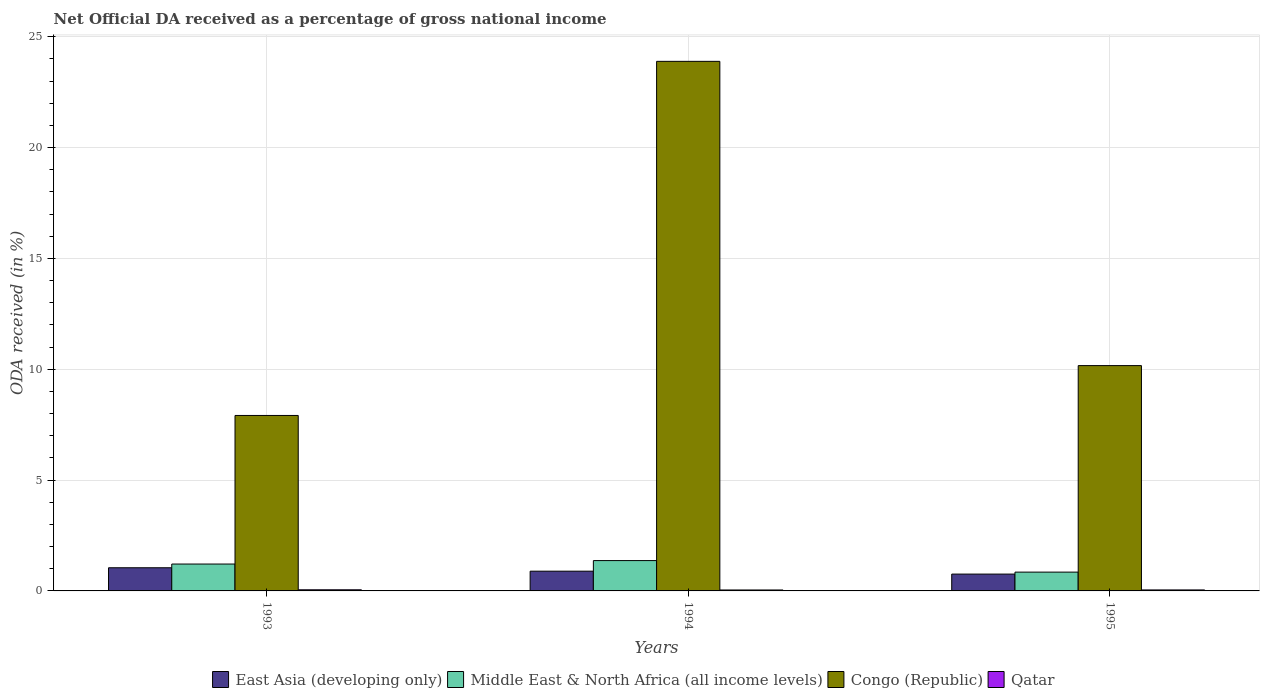Are the number of bars per tick equal to the number of legend labels?
Offer a very short reply. Yes. Are the number of bars on each tick of the X-axis equal?
Ensure brevity in your answer.  Yes. How many bars are there on the 1st tick from the right?
Make the answer very short. 4. What is the label of the 2nd group of bars from the left?
Provide a succinct answer. 1994. In how many cases, is the number of bars for a given year not equal to the number of legend labels?
Keep it short and to the point. 0. What is the net official DA received in Middle East & North Africa (all income levels) in 1994?
Offer a very short reply. 1.37. Across all years, what is the maximum net official DA received in East Asia (developing only)?
Your answer should be compact. 1.05. Across all years, what is the minimum net official DA received in East Asia (developing only)?
Your answer should be compact. 0.76. In which year was the net official DA received in Middle East & North Africa (all income levels) maximum?
Ensure brevity in your answer.  1994. In which year was the net official DA received in Qatar minimum?
Keep it short and to the point. 1994. What is the total net official DA received in East Asia (developing only) in the graph?
Offer a terse response. 2.7. What is the difference between the net official DA received in Congo (Republic) in 1993 and that in 1994?
Provide a succinct answer. -15.98. What is the difference between the net official DA received in East Asia (developing only) in 1993 and the net official DA received in Qatar in 1994?
Keep it short and to the point. 1. What is the average net official DA received in East Asia (developing only) per year?
Make the answer very short. 0.9. In the year 1993, what is the difference between the net official DA received in Qatar and net official DA received in East Asia (developing only)?
Provide a succinct answer. -0.99. In how many years, is the net official DA received in Congo (Republic) greater than 2 %?
Give a very brief answer. 3. What is the ratio of the net official DA received in Qatar in 1993 to that in 1995?
Make the answer very short. 1.15. Is the net official DA received in Middle East & North Africa (all income levels) in 1993 less than that in 1995?
Offer a very short reply. No. Is the difference between the net official DA received in Qatar in 1993 and 1995 greater than the difference between the net official DA received in East Asia (developing only) in 1993 and 1995?
Make the answer very short. No. What is the difference between the highest and the second highest net official DA received in Congo (Republic)?
Make the answer very short. 13.73. What is the difference between the highest and the lowest net official DA received in Middle East & North Africa (all income levels)?
Keep it short and to the point. 0.52. In how many years, is the net official DA received in Middle East & North Africa (all income levels) greater than the average net official DA received in Middle East & North Africa (all income levels) taken over all years?
Your answer should be very brief. 2. Is it the case that in every year, the sum of the net official DA received in Qatar and net official DA received in Middle East & North Africa (all income levels) is greater than the sum of net official DA received in Congo (Republic) and net official DA received in East Asia (developing only)?
Your answer should be very brief. No. What does the 2nd bar from the left in 1993 represents?
Keep it short and to the point. Middle East & North Africa (all income levels). What does the 4th bar from the right in 1994 represents?
Your answer should be compact. East Asia (developing only). Is it the case that in every year, the sum of the net official DA received in Congo (Republic) and net official DA received in East Asia (developing only) is greater than the net official DA received in Middle East & North Africa (all income levels)?
Make the answer very short. Yes. How many bars are there?
Offer a terse response. 12. Are all the bars in the graph horizontal?
Give a very brief answer. No. How many years are there in the graph?
Keep it short and to the point. 3. Where does the legend appear in the graph?
Offer a terse response. Bottom center. How many legend labels are there?
Ensure brevity in your answer.  4. How are the legend labels stacked?
Your response must be concise. Horizontal. What is the title of the graph?
Provide a short and direct response. Net Official DA received as a percentage of gross national income. What is the label or title of the X-axis?
Your answer should be compact. Years. What is the label or title of the Y-axis?
Provide a succinct answer. ODA received (in %). What is the ODA received (in %) of East Asia (developing only) in 1993?
Ensure brevity in your answer.  1.05. What is the ODA received (in %) in Middle East & North Africa (all income levels) in 1993?
Make the answer very short. 1.21. What is the ODA received (in %) of Congo (Republic) in 1993?
Give a very brief answer. 7.92. What is the ODA received (in %) of Qatar in 1993?
Offer a very short reply. 0.05. What is the ODA received (in %) of East Asia (developing only) in 1994?
Your response must be concise. 0.89. What is the ODA received (in %) in Middle East & North Africa (all income levels) in 1994?
Your response must be concise. 1.37. What is the ODA received (in %) in Congo (Republic) in 1994?
Your answer should be compact. 23.89. What is the ODA received (in %) of Qatar in 1994?
Keep it short and to the point. 0.04. What is the ODA received (in %) in East Asia (developing only) in 1995?
Your answer should be compact. 0.76. What is the ODA received (in %) in Middle East & North Africa (all income levels) in 1995?
Provide a succinct answer. 0.85. What is the ODA received (in %) in Congo (Republic) in 1995?
Ensure brevity in your answer.  10.17. What is the ODA received (in %) of Qatar in 1995?
Offer a terse response. 0.04. Across all years, what is the maximum ODA received (in %) in East Asia (developing only)?
Your answer should be very brief. 1.05. Across all years, what is the maximum ODA received (in %) in Middle East & North Africa (all income levels)?
Your answer should be very brief. 1.37. Across all years, what is the maximum ODA received (in %) in Congo (Republic)?
Your response must be concise. 23.89. Across all years, what is the maximum ODA received (in %) of Qatar?
Offer a terse response. 0.05. Across all years, what is the minimum ODA received (in %) in East Asia (developing only)?
Your answer should be compact. 0.76. Across all years, what is the minimum ODA received (in %) of Middle East & North Africa (all income levels)?
Provide a succinct answer. 0.85. Across all years, what is the minimum ODA received (in %) in Congo (Republic)?
Your response must be concise. 7.92. Across all years, what is the minimum ODA received (in %) in Qatar?
Your response must be concise. 0.04. What is the total ODA received (in %) of East Asia (developing only) in the graph?
Offer a terse response. 2.7. What is the total ODA received (in %) in Middle East & North Africa (all income levels) in the graph?
Make the answer very short. 3.43. What is the total ODA received (in %) in Congo (Republic) in the graph?
Your response must be concise. 41.97. What is the total ODA received (in %) in Qatar in the graph?
Your answer should be compact. 0.14. What is the difference between the ODA received (in %) in East Asia (developing only) in 1993 and that in 1994?
Offer a very short reply. 0.15. What is the difference between the ODA received (in %) in Middle East & North Africa (all income levels) in 1993 and that in 1994?
Your answer should be compact. -0.16. What is the difference between the ODA received (in %) in Congo (Republic) in 1993 and that in 1994?
Your answer should be very brief. -15.98. What is the difference between the ODA received (in %) in Qatar in 1993 and that in 1994?
Give a very brief answer. 0.01. What is the difference between the ODA received (in %) in East Asia (developing only) in 1993 and that in 1995?
Keep it short and to the point. 0.29. What is the difference between the ODA received (in %) in Middle East & North Africa (all income levels) in 1993 and that in 1995?
Keep it short and to the point. 0.36. What is the difference between the ODA received (in %) of Congo (Republic) in 1993 and that in 1995?
Give a very brief answer. -2.25. What is the difference between the ODA received (in %) of Qatar in 1993 and that in 1995?
Offer a very short reply. 0.01. What is the difference between the ODA received (in %) in East Asia (developing only) in 1994 and that in 1995?
Keep it short and to the point. 0.13. What is the difference between the ODA received (in %) in Middle East & North Africa (all income levels) in 1994 and that in 1995?
Your response must be concise. 0.52. What is the difference between the ODA received (in %) in Congo (Republic) in 1994 and that in 1995?
Provide a succinct answer. 13.73. What is the difference between the ODA received (in %) in Qatar in 1994 and that in 1995?
Your answer should be compact. -0. What is the difference between the ODA received (in %) in East Asia (developing only) in 1993 and the ODA received (in %) in Middle East & North Africa (all income levels) in 1994?
Offer a terse response. -0.32. What is the difference between the ODA received (in %) in East Asia (developing only) in 1993 and the ODA received (in %) in Congo (Republic) in 1994?
Ensure brevity in your answer.  -22.85. What is the difference between the ODA received (in %) of Middle East & North Africa (all income levels) in 1993 and the ODA received (in %) of Congo (Republic) in 1994?
Provide a short and direct response. -22.68. What is the difference between the ODA received (in %) in Middle East & North Africa (all income levels) in 1993 and the ODA received (in %) in Qatar in 1994?
Provide a succinct answer. 1.17. What is the difference between the ODA received (in %) in Congo (Republic) in 1993 and the ODA received (in %) in Qatar in 1994?
Give a very brief answer. 7.87. What is the difference between the ODA received (in %) in East Asia (developing only) in 1993 and the ODA received (in %) in Middle East & North Africa (all income levels) in 1995?
Offer a terse response. 0.2. What is the difference between the ODA received (in %) in East Asia (developing only) in 1993 and the ODA received (in %) in Congo (Republic) in 1995?
Keep it short and to the point. -9.12. What is the difference between the ODA received (in %) in East Asia (developing only) in 1993 and the ODA received (in %) in Qatar in 1995?
Make the answer very short. 1. What is the difference between the ODA received (in %) in Middle East & North Africa (all income levels) in 1993 and the ODA received (in %) in Congo (Republic) in 1995?
Make the answer very short. -8.95. What is the difference between the ODA received (in %) of Middle East & North Africa (all income levels) in 1993 and the ODA received (in %) of Qatar in 1995?
Keep it short and to the point. 1.17. What is the difference between the ODA received (in %) of Congo (Republic) in 1993 and the ODA received (in %) of Qatar in 1995?
Provide a short and direct response. 7.87. What is the difference between the ODA received (in %) in East Asia (developing only) in 1994 and the ODA received (in %) in Middle East & North Africa (all income levels) in 1995?
Keep it short and to the point. 0.04. What is the difference between the ODA received (in %) in East Asia (developing only) in 1994 and the ODA received (in %) in Congo (Republic) in 1995?
Your answer should be compact. -9.27. What is the difference between the ODA received (in %) of East Asia (developing only) in 1994 and the ODA received (in %) of Qatar in 1995?
Provide a short and direct response. 0.85. What is the difference between the ODA received (in %) in Middle East & North Africa (all income levels) in 1994 and the ODA received (in %) in Congo (Republic) in 1995?
Offer a terse response. -8.8. What is the difference between the ODA received (in %) of Middle East & North Africa (all income levels) in 1994 and the ODA received (in %) of Qatar in 1995?
Keep it short and to the point. 1.32. What is the difference between the ODA received (in %) of Congo (Republic) in 1994 and the ODA received (in %) of Qatar in 1995?
Give a very brief answer. 23.85. What is the average ODA received (in %) of East Asia (developing only) per year?
Give a very brief answer. 0.9. What is the average ODA received (in %) in Middle East & North Africa (all income levels) per year?
Give a very brief answer. 1.14. What is the average ODA received (in %) in Congo (Republic) per year?
Your response must be concise. 13.99. What is the average ODA received (in %) of Qatar per year?
Make the answer very short. 0.05. In the year 1993, what is the difference between the ODA received (in %) of East Asia (developing only) and ODA received (in %) of Middle East & North Africa (all income levels)?
Make the answer very short. -0.17. In the year 1993, what is the difference between the ODA received (in %) of East Asia (developing only) and ODA received (in %) of Congo (Republic)?
Your answer should be compact. -6.87. In the year 1993, what is the difference between the ODA received (in %) in Middle East & North Africa (all income levels) and ODA received (in %) in Congo (Republic)?
Your answer should be compact. -6.7. In the year 1993, what is the difference between the ODA received (in %) of Middle East & North Africa (all income levels) and ODA received (in %) of Qatar?
Ensure brevity in your answer.  1.16. In the year 1993, what is the difference between the ODA received (in %) in Congo (Republic) and ODA received (in %) in Qatar?
Give a very brief answer. 7.87. In the year 1994, what is the difference between the ODA received (in %) in East Asia (developing only) and ODA received (in %) in Middle East & North Africa (all income levels)?
Your response must be concise. -0.48. In the year 1994, what is the difference between the ODA received (in %) of East Asia (developing only) and ODA received (in %) of Congo (Republic)?
Provide a short and direct response. -23. In the year 1994, what is the difference between the ODA received (in %) in East Asia (developing only) and ODA received (in %) in Qatar?
Ensure brevity in your answer.  0.85. In the year 1994, what is the difference between the ODA received (in %) of Middle East & North Africa (all income levels) and ODA received (in %) of Congo (Republic)?
Make the answer very short. -22.52. In the year 1994, what is the difference between the ODA received (in %) of Middle East & North Africa (all income levels) and ODA received (in %) of Qatar?
Give a very brief answer. 1.33. In the year 1994, what is the difference between the ODA received (in %) of Congo (Republic) and ODA received (in %) of Qatar?
Offer a very short reply. 23.85. In the year 1995, what is the difference between the ODA received (in %) in East Asia (developing only) and ODA received (in %) in Middle East & North Africa (all income levels)?
Make the answer very short. -0.09. In the year 1995, what is the difference between the ODA received (in %) of East Asia (developing only) and ODA received (in %) of Congo (Republic)?
Give a very brief answer. -9.41. In the year 1995, what is the difference between the ODA received (in %) of East Asia (developing only) and ODA received (in %) of Qatar?
Ensure brevity in your answer.  0.71. In the year 1995, what is the difference between the ODA received (in %) in Middle East & North Africa (all income levels) and ODA received (in %) in Congo (Republic)?
Your answer should be very brief. -9.32. In the year 1995, what is the difference between the ODA received (in %) in Middle East & North Africa (all income levels) and ODA received (in %) in Qatar?
Your answer should be compact. 0.8. In the year 1995, what is the difference between the ODA received (in %) of Congo (Republic) and ODA received (in %) of Qatar?
Your response must be concise. 10.12. What is the ratio of the ODA received (in %) in East Asia (developing only) in 1993 to that in 1994?
Provide a succinct answer. 1.17. What is the ratio of the ODA received (in %) in Middle East & North Africa (all income levels) in 1993 to that in 1994?
Your answer should be compact. 0.89. What is the ratio of the ODA received (in %) of Congo (Republic) in 1993 to that in 1994?
Provide a succinct answer. 0.33. What is the ratio of the ODA received (in %) in Qatar in 1993 to that in 1994?
Make the answer very short. 1.21. What is the ratio of the ODA received (in %) in East Asia (developing only) in 1993 to that in 1995?
Make the answer very short. 1.38. What is the ratio of the ODA received (in %) of Middle East & North Africa (all income levels) in 1993 to that in 1995?
Make the answer very short. 1.43. What is the ratio of the ODA received (in %) in Congo (Republic) in 1993 to that in 1995?
Give a very brief answer. 0.78. What is the ratio of the ODA received (in %) of Qatar in 1993 to that in 1995?
Offer a very short reply. 1.15. What is the ratio of the ODA received (in %) in East Asia (developing only) in 1994 to that in 1995?
Ensure brevity in your answer.  1.17. What is the ratio of the ODA received (in %) in Middle East & North Africa (all income levels) in 1994 to that in 1995?
Your answer should be very brief. 1.61. What is the ratio of the ODA received (in %) of Congo (Republic) in 1994 to that in 1995?
Your answer should be compact. 2.35. What is the ratio of the ODA received (in %) of Qatar in 1994 to that in 1995?
Provide a short and direct response. 0.95. What is the difference between the highest and the second highest ODA received (in %) in East Asia (developing only)?
Make the answer very short. 0.15. What is the difference between the highest and the second highest ODA received (in %) in Middle East & North Africa (all income levels)?
Give a very brief answer. 0.16. What is the difference between the highest and the second highest ODA received (in %) of Congo (Republic)?
Offer a very short reply. 13.73. What is the difference between the highest and the second highest ODA received (in %) in Qatar?
Give a very brief answer. 0.01. What is the difference between the highest and the lowest ODA received (in %) in East Asia (developing only)?
Keep it short and to the point. 0.29. What is the difference between the highest and the lowest ODA received (in %) in Middle East & North Africa (all income levels)?
Offer a terse response. 0.52. What is the difference between the highest and the lowest ODA received (in %) in Congo (Republic)?
Give a very brief answer. 15.98. What is the difference between the highest and the lowest ODA received (in %) in Qatar?
Your answer should be very brief. 0.01. 